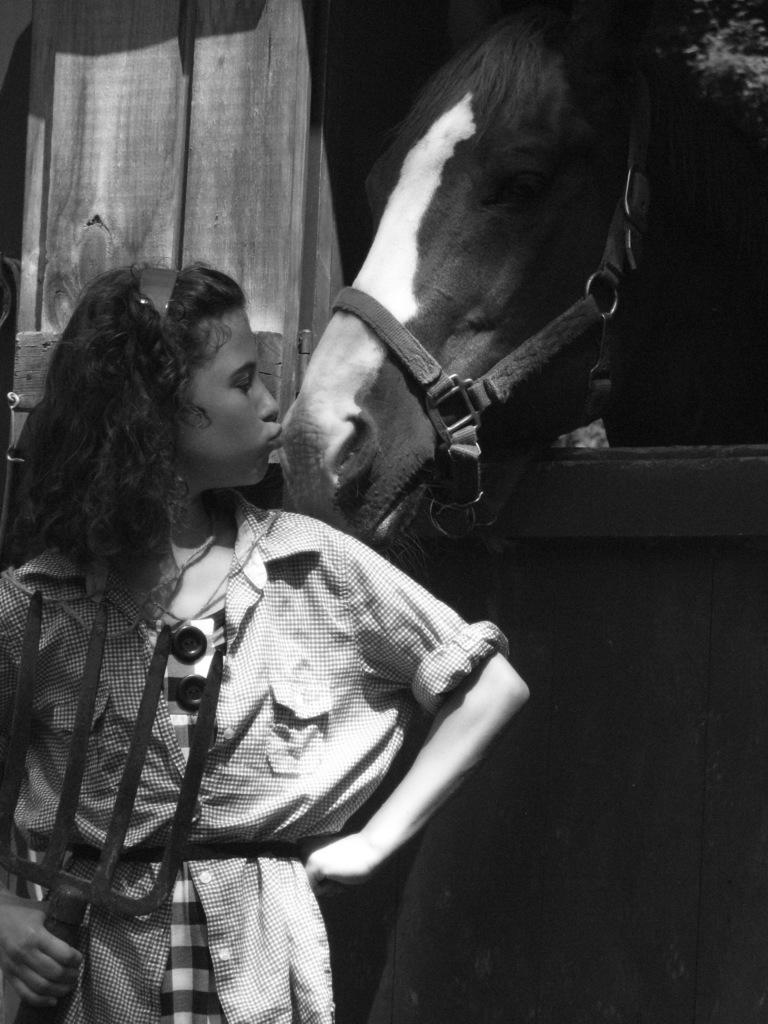Who is the main subject in the image? There is a girl in the image. What is the girl doing in the image? The girl is standing and kissing a horse. What is the girl holding in her hand? The girl is holding an object in her hand. What type of cake is being requested by the girl in the image? There is no cake present in the image, nor is there any indication that the girl is requesting one. 